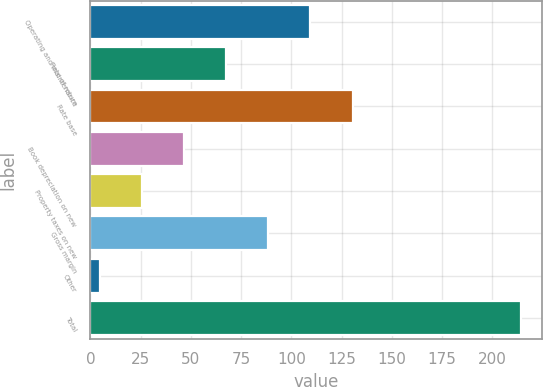<chart> <loc_0><loc_0><loc_500><loc_500><bar_chart><fcel>Operating and maintenance<fcel>Rate of return<fcel>Rate base<fcel>Book depreciation on new<fcel>Property taxes on new<fcel>Gross margin<fcel>Other<fcel>Total<nl><fcel>109.5<fcel>67.7<fcel>130.4<fcel>46.8<fcel>25.9<fcel>88.6<fcel>5<fcel>214<nl></chart> 